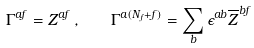Convert formula to latex. <formula><loc_0><loc_0><loc_500><loc_500>\Gamma ^ { a f } = Z ^ { a f } \, , \quad \Gamma ^ { a ( N _ { f } + f ) } = \sum _ { b } \epsilon ^ { a b } \overline { Z } ^ { b f }</formula> 